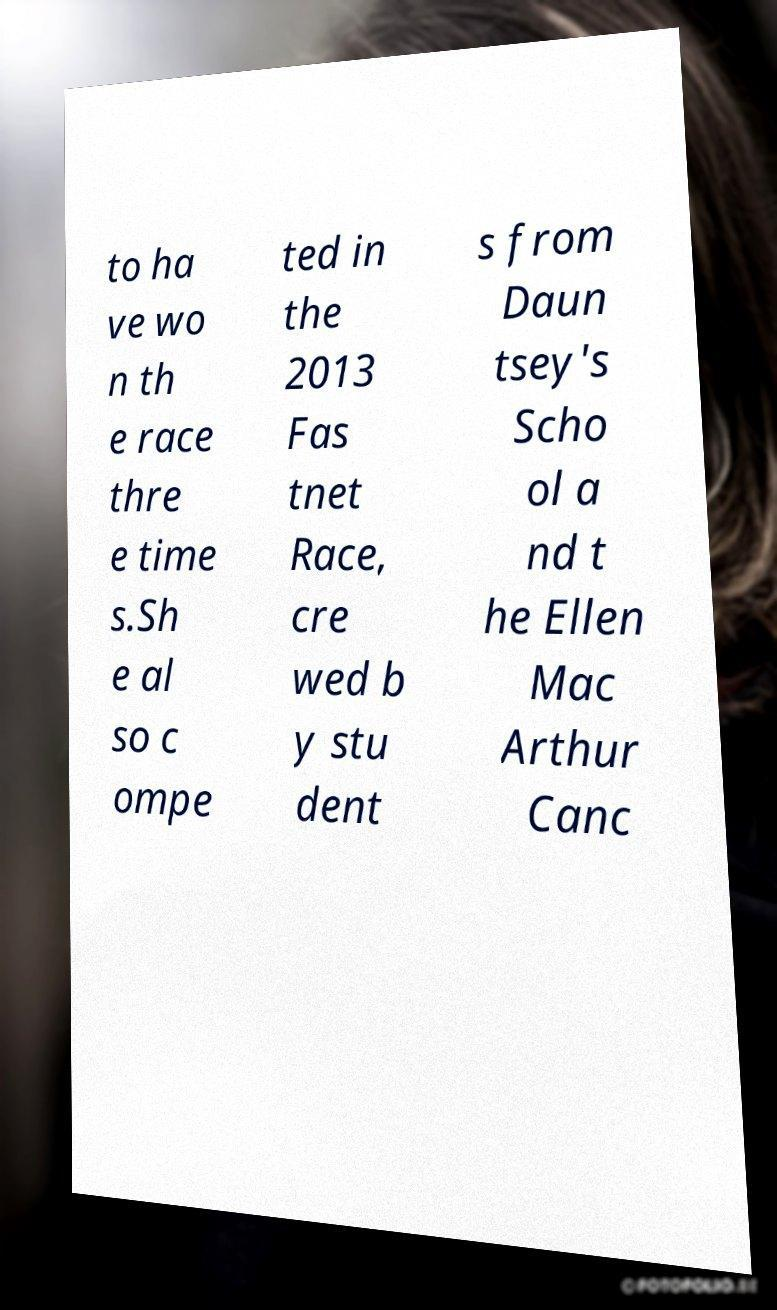Please read and relay the text visible in this image. What does it say? to ha ve wo n th e race thre e time s.Sh e al so c ompe ted in the 2013 Fas tnet Race, cre wed b y stu dent s from Daun tsey's Scho ol a nd t he Ellen Mac Arthur Canc 